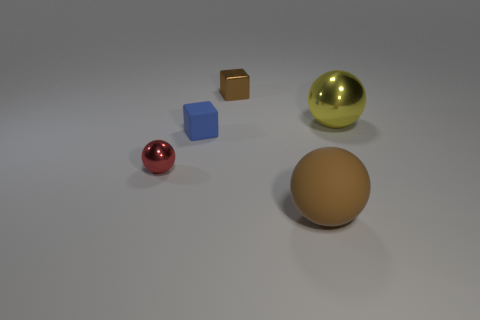Are there any other things that are the same shape as the tiny matte thing? Yes, the shape of the tiny matte cube is similar to the shape of the larger, reflective cube in the image, indicating that both objects are geometrically cubic despite the difference in size and texture. 